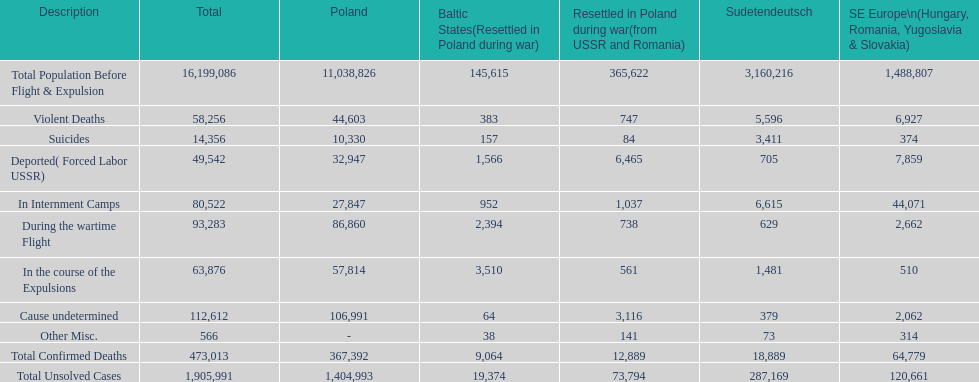Which zone had the lowest total of uncracked cases? Baltic States(Resettled in Poland during war). 